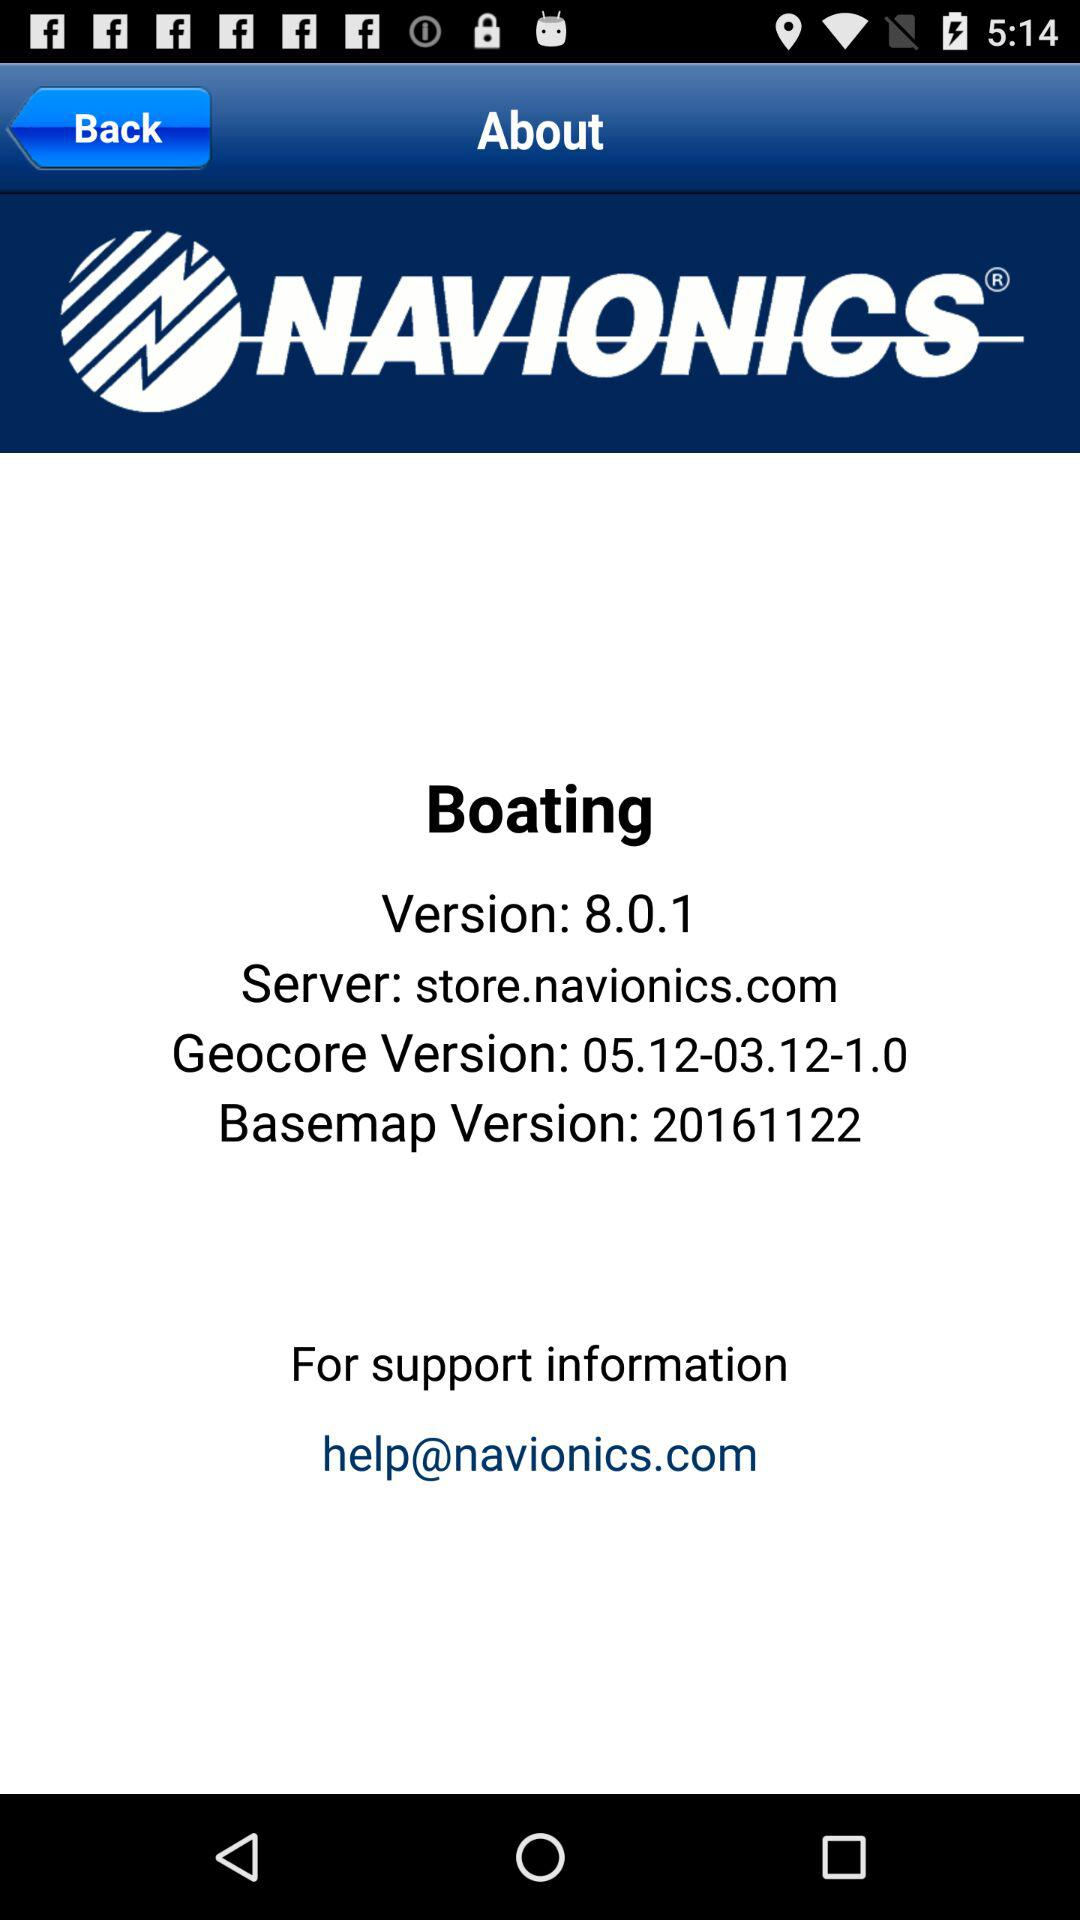Where can we go for support information? The address where we can go for support information is "help@navionics.com". 